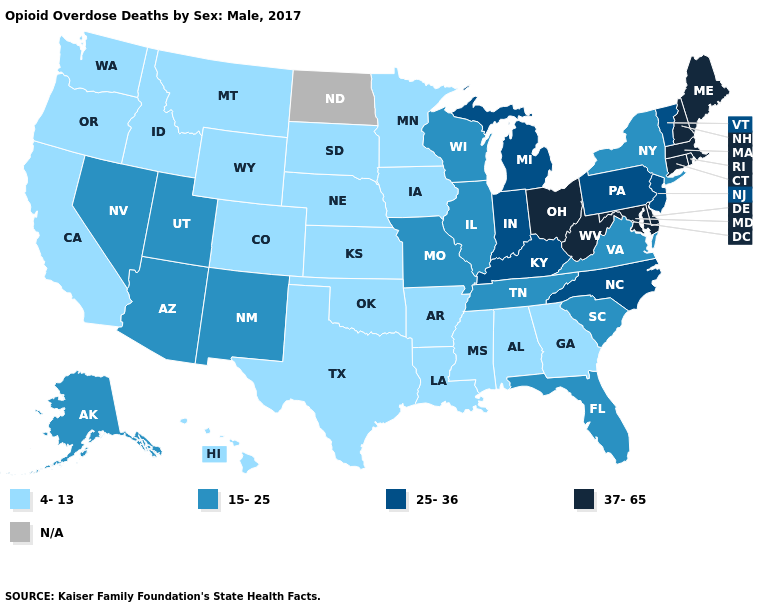What is the value of West Virginia?
Be succinct. 37-65. What is the value of Louisiana?
Keep it brief. 4-13. Which states have the highest value in the USA?
Write a very short answer. Connecticut, Delaware, Maine, Maryland, Massachusetts, New Hampshire, Ohio, Rhode Island, West Virginia. What is the highest value in the Northeast ?
Give a very brief answer. 37-65. What is the value of North Carolina?
Write a very short answer. 25-36. What is the value of Illinois?
Give a very brief answer. 15-25. What is the highest value in the South ?
Concise answer only. 37-65. Name the states that have a value in the range 15-25?
Concise answer only. Alaska, Arizona, Florida, Illinois, Missouri, Nevada, New Mexico, New York, South Carolina, Tennessee, Utah, Virginia, Wisconsin. Name the states that have a value in the range 15-25?
Answer briefly. Alaska, Arizona, Florida, Illinois, Missouri, Nevada, New Mexico, New York, South Carolina, Tennessee, Utah, Virginia, Wisconsin. Name the states that have a value in the range 15-25?
Quick response, please. Alaska, Arizona, Florida, Illinois, Missouri, Nevada, New Mexico, New York, South Carolina, Tennessee, Utah, Virginia, Wisconsin. What is the value of Mississippi?
Short answer required. 4-13. What is the value of West Virginia?
Short answer required. 37-65. Which states have the highest value in the USA?
Write a very short answer. Connecticut, Delaware, Maine, Maryland, Massachusetts, New Hampshire, Ohio, Rhode Island, West Virginia. 